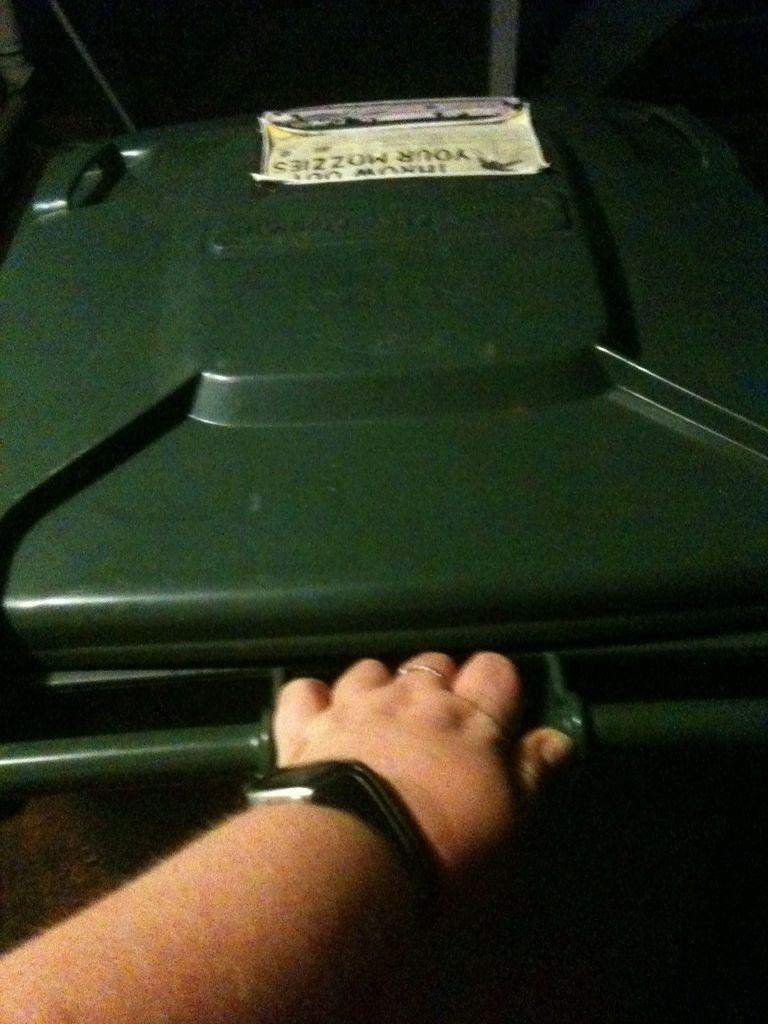What color is the suitcase in the picture? The suitcase in the picture is green. Can you describe any other details about the suitcase? Yes, a person's hand is visible at the front bottom side of the suitcase. What type of star can be seen on the suitcase in the image? There is no star visible on the suitcase in the image. Is there a cannon present in the image? No, there is no cannon present in the image. 